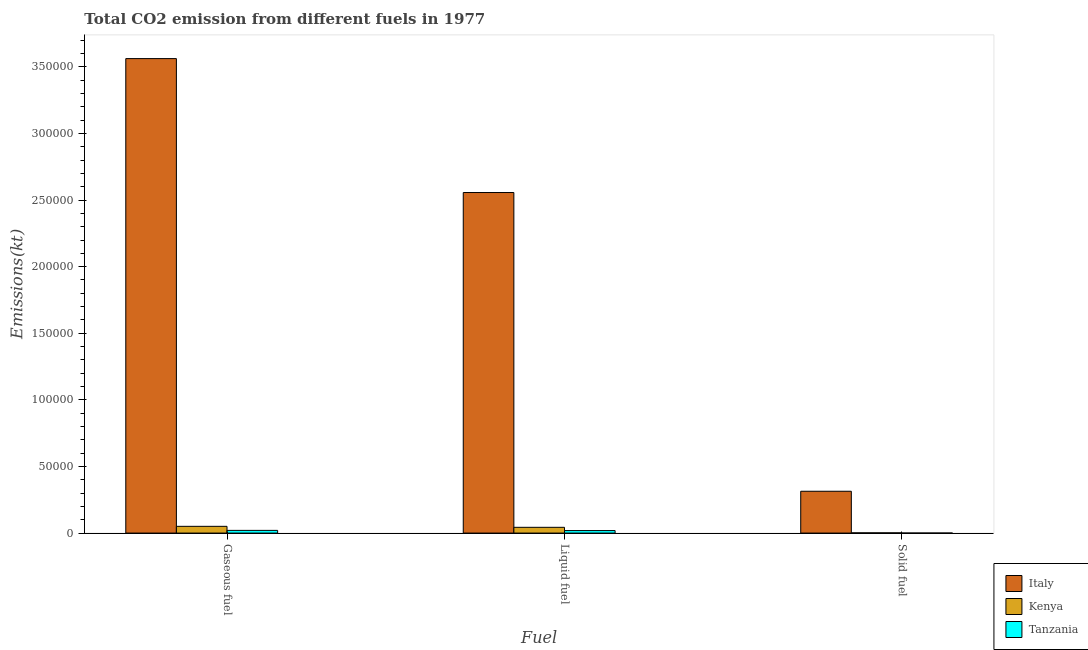Are the number of bars on each tick of the X-axis equal?
Offer a terse response. Yes. How many bars are there on the 3rd tick from the left?
Keep it short and to the point. 3. How many bars are there on the 2nd tick from the right?
Provide a short and direct response. 3. What is the label of the 2nd group of bars from the left?
Give a very brief answer. Liquid fuel. What is the amount of co2 emissions from liquid fuel in Kenya?
Make the answer very short. 4316.06. Across all countries, what is the maximum amount of co2 emissions from solid fuel?
Give a very brief answer. 3.14e+04. Across all countries, what is the minimum amount of co2 emissions from liquid fuel?
Your response must be concise. 1873.84. In which country was the amount of co2 emissions from gaseous fuel maximum?
Keep it short and to the point. Italy. In which country was the amount of co2 emissions from liquid fuel minimum?
Offer a terse response. Tanzania. What is the total amount of co2 emissions from gaseous fuel in the graph?
Ensure brevity in your answer.  3.63e+05. What is the difference between the amount of co2 emissions from liquid fuel in Tanzania and that in Italy?
Offer a terse response. -2.54e+05. What is the difference between the amount of co2 emissions from liquid fuel in Tanzania and the amount of co2 emissions from solid fuel in Kenya?
Give a very brief answer. 1705.15. What is the average amount of co2 emissions from gaseous fuel per country?
Offer a terse response. 1.21e+05. What is the difference between the amount of co2 emissions from liquid fuel and amount of co2 emissions from solid fuel in Kenya?
Keep it short and to the point. 4147.38. What is the ratio of the amount of co2 emissions from gaseous fuel in Tanzania to that in Italy?
Provide a short and direct response. 0.01. Is the amount of co2 emissions from gaseous fuel in Tanzania less than that in Italy?
Provide a succinct answer. Yes. What is the difference between the highest and the second highest amount of co2 emissions from liquid fuel?
Ensure brevity in your answer.  2.51e+05. What is the difference between the highest and the lowest amount of co2 emissions from liquid fuel?
Your response must be concise. 2.54e+05. In how many countries, is the amount of co2 emissions from solid fuel greater than the average amount of co2 emissions from solid fuel taken over all countries?
Your response must be concise. 1. Is the sum of the amount of co2 emissions from liquid fuel in Kenya and Tanzania greater than the maximum amount of co2 emissions from gaseous fuel across all countries?
Your answer should be compact. No. What does the 3rd bar from the left in Liquid fuel represents?
Keep it short and to the point. Tanzania. Is it the case that in every country, the sum of the amount of co2 emissions from gaseous fuel and amount of co2 emissions from liquid fuel is greater than the amount of co2 emissions from solid fuel?
Ensure brevity in your answer.  Yes. How many countries are there in the graph?
Ensure brevity in your answer.  3. What is the difference between two consecutive major ticks on the Y-axis?
Give a very brief answer. 5.00e+04. Are the values on the major ticks of Y-axis written in scientific E-notation?
Offer a terse response. No. Does the graph contain any zero values?
Provide a succinct answer. No. Where does the legend appear in the graph?
Give a very brief answer. Bottom right. What is the title of the graph?
Make the answer very short. Total CO2 emission from different fuels in 1977. What is the label or title of the X-axis?
Your answer should be very brief. Fuel. What is the label or title of the Y-axis?
Offer a terse response. Emissions(kt). What is the Emissions(kt) of Italy in Gaseous fuel?
Ensure brevity in your answer.  3.56e+05. What is the Emissions(kt) of Kenya in Gaseous fuel?
Make the answer very short. 5056.79. What is the Emissions(kt) in Tanzania in Gaseous fuel?
Keep it short and to the point. 2013.18. What is the Emissions(kt) of Italy in Liquid fuel?
Offer a very short reply. 2.56e+05. What is the Emissions(kt) of Kenya in Liquid fuel?
Your response must be concise. 4316.06. What is the Emissions(kt) in Tanzania in Liquid fuel?
Ensure brevity in your answer.  1873.84. What is the Emissions(kt) of Italy in Solid fuel?
Provide a short and direct response. 3.14e+04. What is the Emissions(kt) in Kenya in Solid fuel?
Make the answer very short. 168.68. What is the Emissions(kt) in Tanzania in Solid fuel?
Offer a terse response. 11. Across all Fuel, what is the maximum Emissions(kt) of Italy?
Keep it short and to the point. 3.56e+05. Across all Fuel, what is the maximum Emissions(kt) in Kenya?
Your response must be concise. 5056.79. Across all Fuel, what is the maximum Emissions(kt) of Tanzania?
Your answer should be compact. 2013.18. Across all Fuel, what is the minimum Emissions(kt) in Italy?
Your response must be concise. 3.14e+04. Across all Fuel, what is the minimum Emissions(kt) of Kenya?
Your answer should be very brief. 168.68. Across all Fuel, what is the minimum Emissions(kt) of Tanzania?
Offer a very short reply. 11. What is the total Emissions(kt) of Italy in the graph?
Offer a very short reply. 6.43e+05. What is the total Emissions(kt) of Kenya in the graph?
Provide a succinct answer. 9541.53. What is the total Emissions(kt) of Tanzania in the graph?
Make the answer very short. 3898.02. What is the difference between the Emissions(kt) of Italy in Gaseous fuel and that in Liquid fuel?
Provide a succinct answer. 1.01e+05. What is the difference between the Emissions(kt) in Kenya in Gaseous fuel and that in Liquid fuel?
Give a very brief answer. 740.73. What is the difference between the Emissions(kt) in Tanzania in Gaseous fuel and that in Liquid fuel?
Offer a terse response. 139.35. What is the difference between the Emissions(kt) in Italy in Gaseous fuel and that in Solid fuel?
Keep it short and to the point. 3.25e+05. What is the difference between the Emissions(kt) in Kenya in Gaseous fuel and that in Solid fuel?
Your response must be concise. 4888.11. What is the difference between the Emissions(kt) of Tanzania in Gaseous fuel and that in Solid fuel?
Your answer should be compact. 2002.18. What is the difference between the Emissions(kt) in Italy in Liquid fuel and that in Solid fuel?
Ensure brevity in your answer.  2.24e+05. What is the difference between the Emissions(kt) of Kenya in Liquid fuel and that in Solid fuel?
Ensure brevity in your answer.  4147.38. What is the difference between the Emissions(kt) in Tanzania in Liquid fuel and that in Solid fuel?
Your response must be concise. 1862.84. What is the difference between the Emissions(kt) in Italy in Gaseous fuel and the Emissions(kt) in Kenya in Liquid fuel?
Keep it short and to the point. 3.52e+05. What is the difference between the Emissions(kt) of Italy in Gaseous fuel and the Emissions(kt) of Tanzania in Liquid fuel?
Keep it short and to the point. 3.54e+05. What is the difference between the Emissions(kt) in Kenya in Gaseous fuel and the Emissions(kt) in Tanzania in Liquid fuel?
Provide a succinct answer. 3182.96. What is the difference between the Emissions(kt) in Italy in Gaseous fuel and the Emissions(kt) in Kenya in Solid fuel?
Ensure brevity in your answer.  3.56e+05. What is the difference between the Emissions(kt) in Italy in Gaseous fuel and the Emissions(kt) in Tanzania in Solid fuel?
Provide a short and direct response. 3.56e+05. What is the difference between the Emissions(kt) in Kenya in Gaseous fuel and the Emissions(kt) in Tanzania in Solid fuel?
Ensure brevity in your answer.  5045.79. What is the difference between the Emissions(kt) of Italy in Liquid fuel and the Emissions(kt) of Kenya in Solid fuel?
Offer a terse response. 2.55e+05. What is the difference between the Emissions(kt) of Italy in Liquid fuel and the Emissions(kt) of Tanzania in Solid fuel?
Your answer should be very brief. 2.56e+05. What is the difference between the Emissions(kt) of Kenya in Liquid fuel and the Emissions(kt) of Tanzania in Solid fuel?
Ensure brevity in your answer.  4305.06. What is the average Emissions(kt) of Italy per Fuel?
Keep it short and to the point. 2.14e+05. What is the average Emissions(kt) in Kenya per Fuel?
Provide a short and direct response. 3180.51. What is the average Emissions(kt) of Tanzania per Fuel?
Offer a terse response. 1299.34. What is the difference between the Emissions(kt) in Italy and Emissions(kt) in Kenya in Gaseous fuel?
Offer a terse response. 3.51e+05. What is the difference between the Emissions(kt) in Italy and Emissions(kt) in Tanzania in Gaseous fuel?
Make the answer very short. 3.54e+05. What is the difference between the Emissions(kt) of Kenya and Emissions(kt) of Tanzania in Gaseous fuel?
Give a very brief answer. 3043.61. What is the difference between the Emissions(kt) in Italy and Emissions(kt) in Kenya in Liquid fuel?
Provide a succinct answer. 2.51e+05. What is the difference between the Emissions(kt) in Italy and Emissions(kt) in Tanzania in Liquid fuel?
Provide a succinct answer. 2.54e+05. What is the difference between the Emissions(kt) of Kenya and Emissions(kt) of Tanzania in Liquid fuel?
Your answer should be compact. 2442.22. What is the difference between the Emissions(kt) in Italy and Emissions(kt) in Kenya in Solid fuel?
Provide a short and direct response. 3.12e+04. What is the difference between the Emissions(kt) of Italy and Emissions(kt) of Tanzania in Solid fuel?
Provide a short and direct response. 3.14e+04. What is the difference between the Emissions(kt) of Kenya and Emissions(kt) of Tanzania in Solid fuel?
Keep it short and to the point. 157.68. What is the ratio of the Emissions(kt) in Italy in Gaseous fuel to that in Liquid fuel?
Your response must be concise. 1.39. What is the ratio of the Emissions(kt) in Kenya in Gaseous fuel to that in Liquid fuel?
Ensure brevity in your answer.  1.17. What is the ratio of the Emissions(kt) of Tanzania in Gaseous fuel to that in Liquid fuel?
Provide a succinct answer. 1.07. What is the ratio of the Emissions(kt) of Italy in Gaseous fuel to that in Solid fuel?
Offer a terse response. 11.35. What is the ratio of the Emissions(kt) of Kenya in Gaseous fuel to that in Solid fuel?
Give a very brief answer. 29.98. What is the ratio of the Emissions(kt) of Tanzania in Gaseous fuel to that in Solid fuel?
Offer a terse response. 183. What is the ratio of the Emissions(kt) of Italy in Liquid fuel to that in Solid fuel?
Make the answer very short. 8.14. What is the ratio of the Emissions(kt) of Kenya in Liquid fuel to that in Solid fuel?
Provide a short and direct response. 25.59. What is the ratio of the Emissions(kt) of Tanzania in Liquid fuel to that in Solid fuel?
Provide a succinct answer. 170.33. What is the difference between the highest and the second highest Emissions(kt) of Italy?
Offer a terse response. 1.01e+05. What is the difference between the highest and the second highest Emissions(kt) in Kenya?
Your response must be concise. 740.73. What is the difference between the highest and the second highest Emissions(kt) in Tanzania?
Provide a succinct answer. 139.35. What is the difference between the highest and the lowest Emissions(kt) in Italy?
Keep it short and to the point. 3.25e+05. What is the difference between the highest and the lowest Emissions(kt) of Kenya?
Your answer should be very brief. 4888.11. What is the difference between the highest and the lowest Emissions(kt) of Tanzania?
Give a very brief answer. 2002.18. 